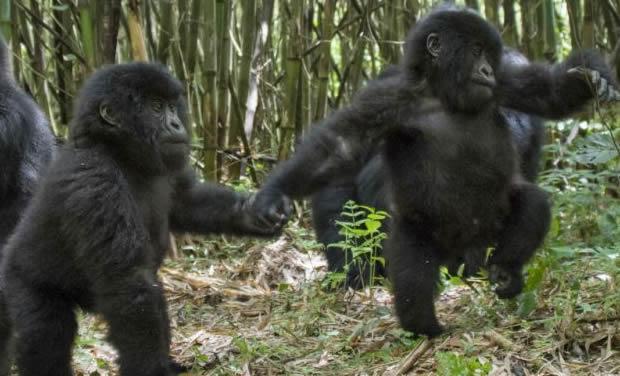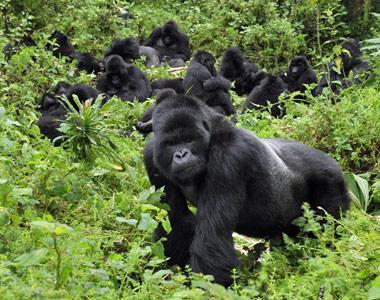The first image is the image on the left, the second image is the image on the right. Considering the images on both sides, is "The left image shows a single silverback male gorilla, and the right image shows a group of gorillas of various ages and sizes." valid? Answer yes or no. No. The first image is the image on the left, the second image is the image on the right. Analyze the images presented: Is the assertion "The left image contains exactly one silver back gorilla." valid? Answer yes or no. No. 